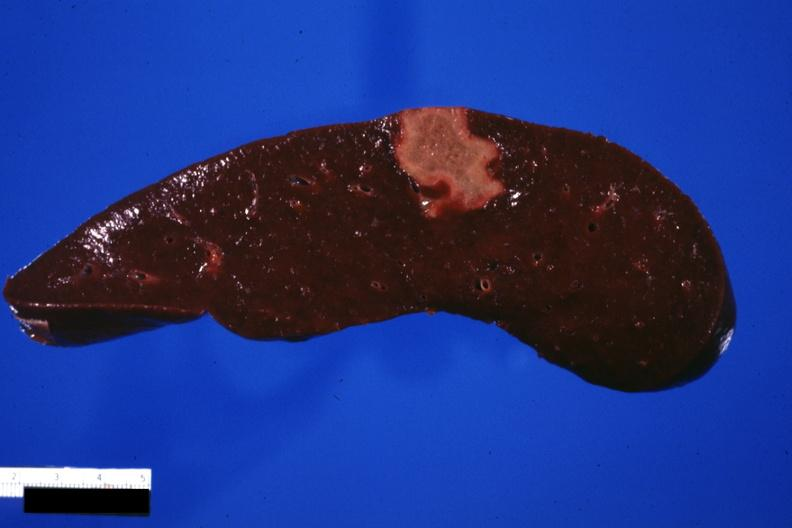what is present?
Answer the question using a single word or phrase. Hematologic 